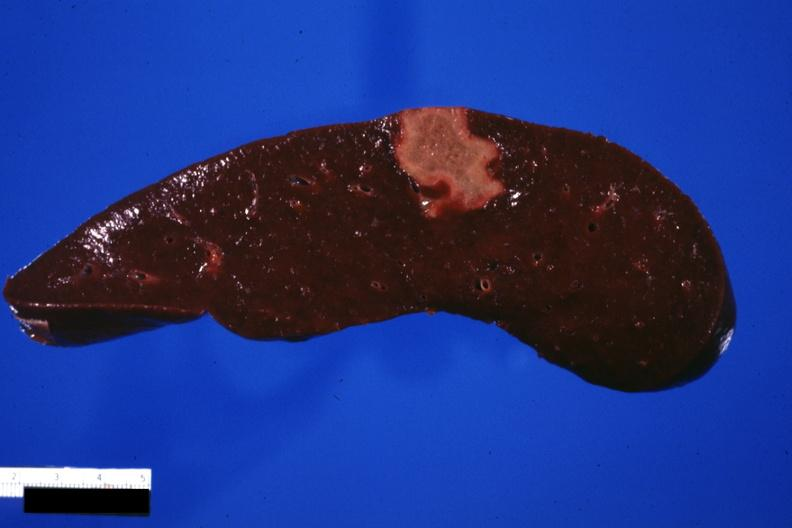what is present?
Answer the question using a single word or phrase. Hematologic 